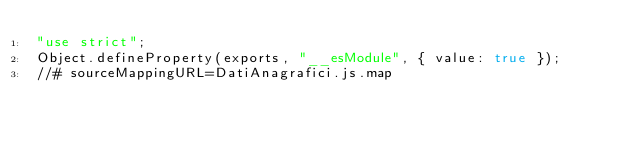Convert code to text. <code><loc_0><loc_0><loc_500><loc_500><_JavaScript_>"use strict";
Object.defineProperty(exports, "__esModule", { value: true });
//# sourceMappingURL=DatiAnagrafici.js.map</code> 